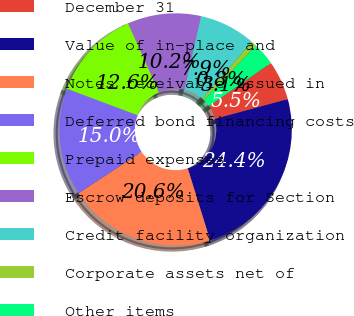<chart> <loc_0><loc_0><loc_500><loc_500><pie_chart><fcel>December 31<fcel>Value of in-place and<fcel>Notes receivable issued in<fcel>Deferred bond financing costs<fcel>Prepaid expenses<fcel>Escrow deposits for Section<fcel>Credit facility organization<fcel>Corporate assets net of<fcel>Other items<nl><fcel>5.5%<fcel>24.41%<fcel>20.55%<fcel>14.95%<fcel>12.59%<fcel>10.23%<fcel>7.86%<fcel>0.77%<fcel>3.13%<nl></chart> 